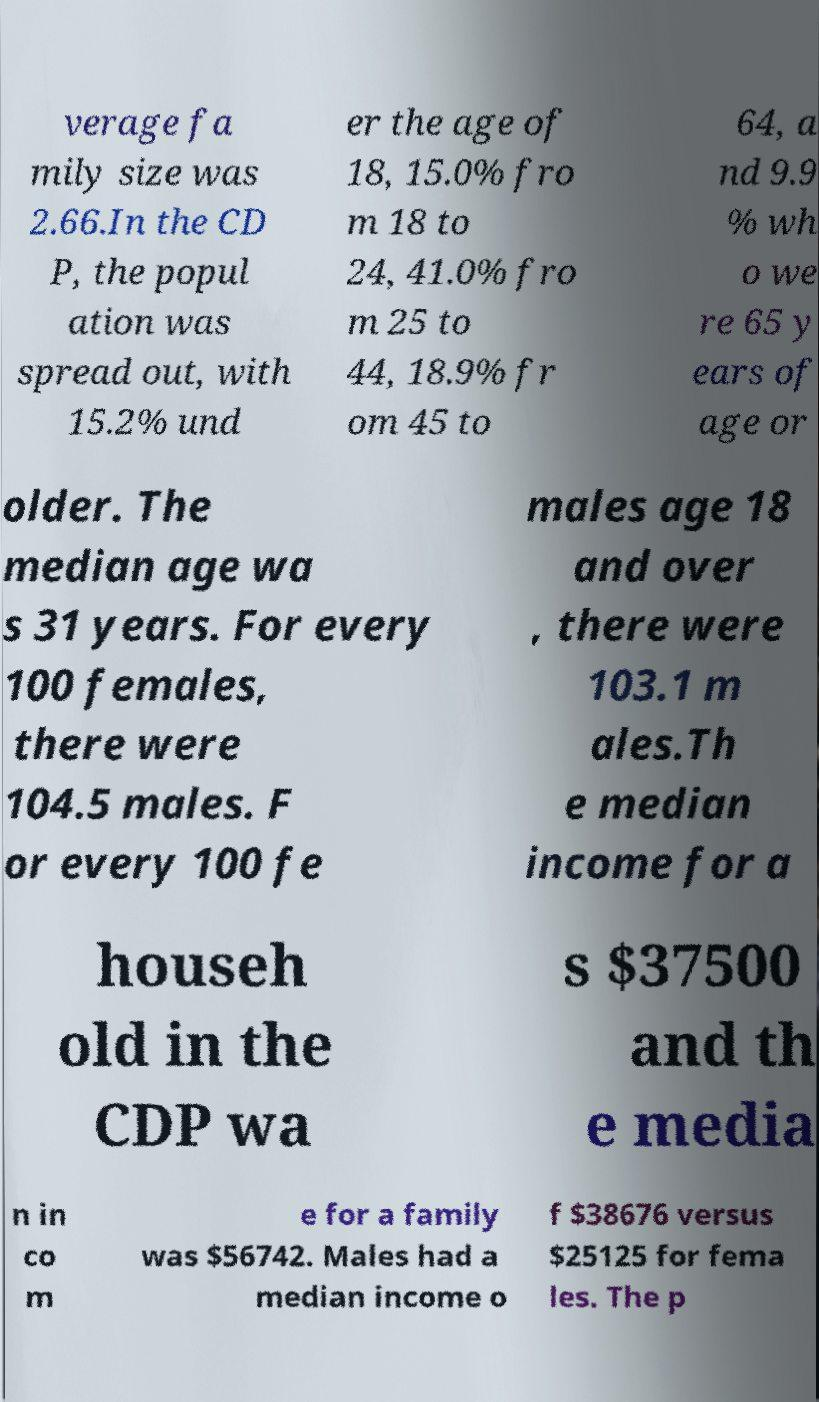Could you extract and type out the text from this image? verage fa mily size was 2.66.In the CD P, the popul ation was spread out, with 15.2% und er the age of 18, 15.0% fro m 18 to 24, 41.0% fro m 25 to 44, 18.9% fr om 45 to 64, a nd 9.9 % wh o we re 65 y ears of age or older. The median age wa s 31 years. For every 100 females, there were 104.5 males. F or every 100 fe males age 18 and over , there were 103.1 m ales.Th e median income for a househ old in the CDP wa s $37500 and th e media n in co m e for a family was $56742. Males had a median income o f $38676 versus $25125 for fema les. The p 